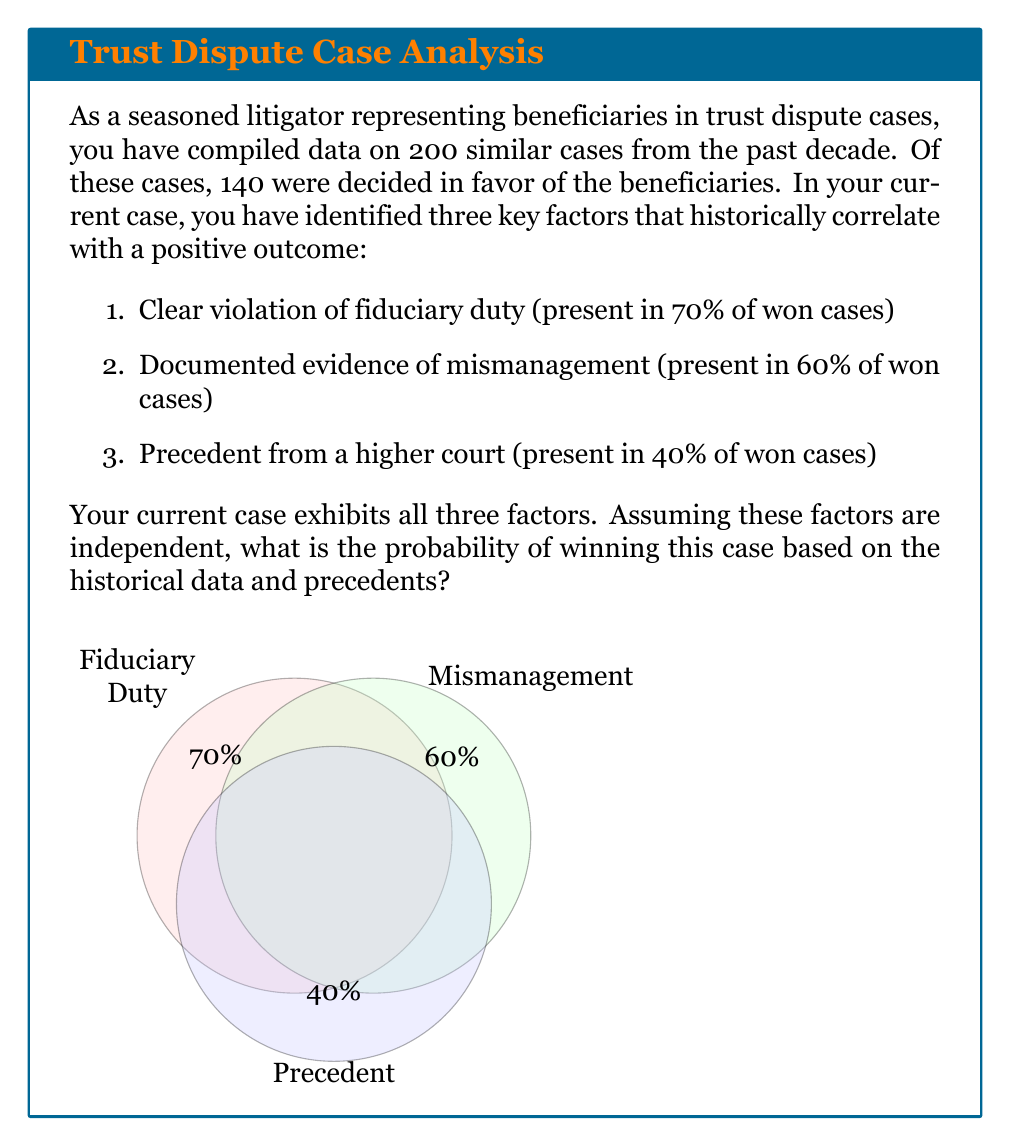Give your solution to this math problem. Let's approach this step-by-step:

1) First, we need to calculate the base probability of winning a case:
   $$P(\text{Win}) = \frac{\text{Number of won cases}}{\text{Total number of cases}} = \frac{140}{200} = 0.7$$

2) Now, we need to calculate the probability of winning given all three factors are present. We can use Bayes' theorem for this:

   $$P(W|F) = \frac{P(F|W) \cdot P(W)}{P(F)}$$

   Where:
   $W$ is the event of winning the case
   $F$ is the event of all three factors being present

3) We know $P(W) = 0.7$ from step 1.

4) To calculate $P(F|W)$, we multiply the probabilities of each factor being present in won cases:
   $$P(F|W) = 0.7 \cdot 0.6 \cdot 0.4 = 0.168$$

5) To calculate $P(F)$, we need to consider both won and lost cases:
   $$P(F) = P(F|W) \cdot P(W) + P(F|\text{not }W) \cdot P(\text{not }W)$$

   We don't have direct information about $P(F|\text{not }W)$, but we can estimate it based on the given information:
   
   $$P(F|\text{not }W) \approx (1-0.7) \cdot (1-0.6) \cdot (1-0.4) = 0.072$$

   $$P(F) = 0.168 \cdot 0.7 + 0.072 \cdot 0.3 = 0.1392$$

6) Now we can apply Bayes' theorem:

   $$P(W|F) = \frac{0.168 \cdot 0.7}{0.1392} \approx 0.8448$$

Therefore, based on the historical data and precedents, the probability of winning this case is approximately 84.48%.
Answer: $0.8448$ or $84.48\%$ 